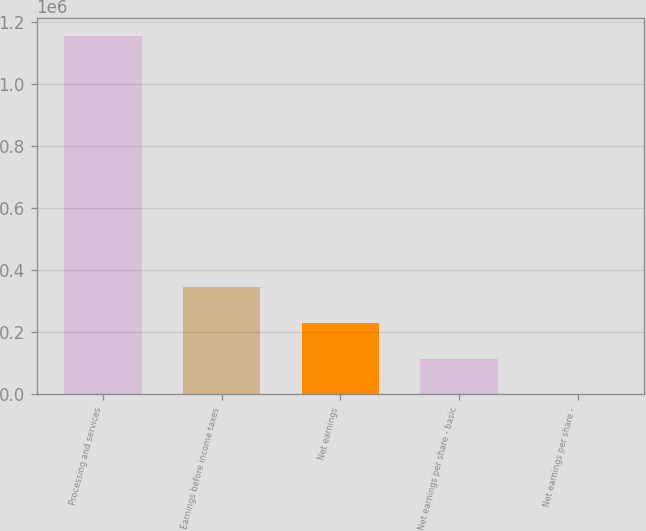<chart> <loc_0><loc_0><loc_500><loc_500><bar_chart><fcel>Processing and services<fcel>Earnings before income taxes<fcel>Net earnings<fcel>Net earnings per share - basic<fcel>Net earnings per share -<nl><fcel>1.15651e+06<fcel>346953<fcel>231302<fcel>115651<fcel>0.75<nl></chart> 